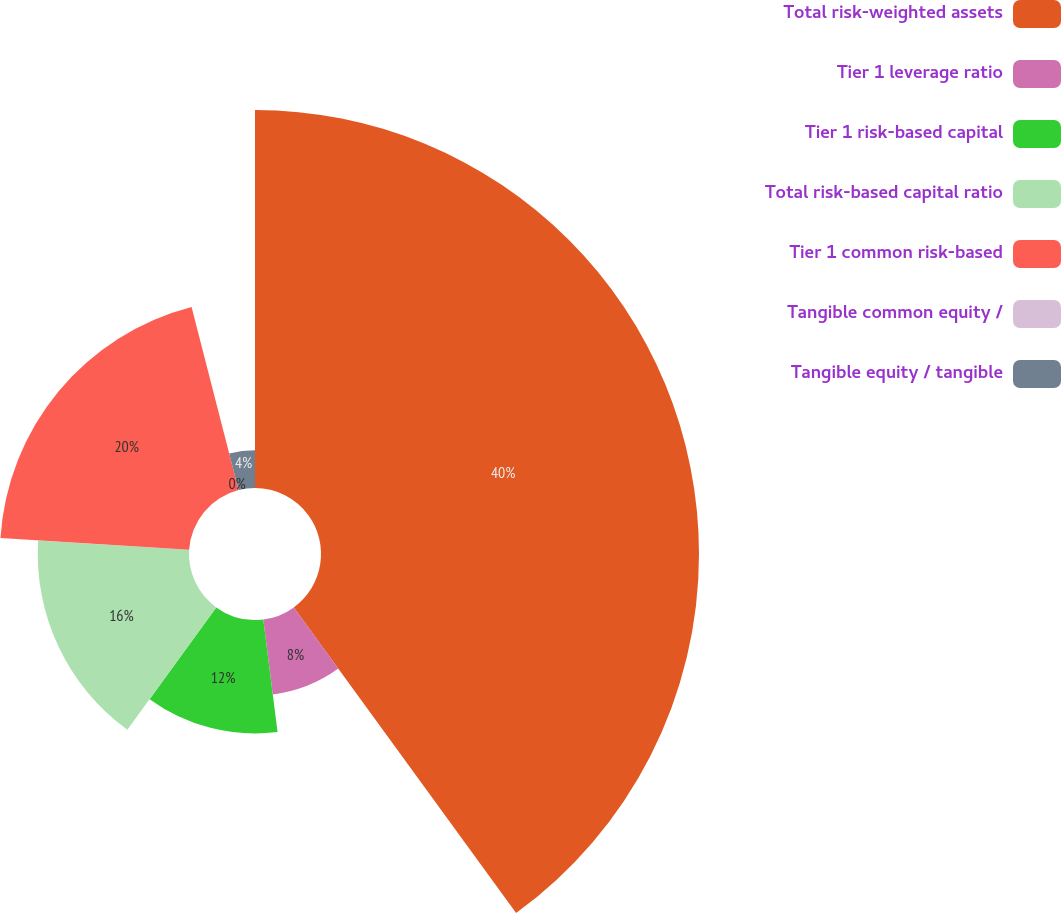Convert chart. <chart><loc_0><loc_0><loc_500><loc_500><pie_chart><fcel>Total risk-weighted assets<fcel>Tier 1 leverage ratio<fcel>Tier 1 risk-based capital<fcel>Total risk-based capital ratio<fcel>Tier 1 common risk-based<fcel>Tangible common equity /<fcel>Tangible equity / tangible<nl><fcel>39.99%<fcel>8.0%<fcel>12.0%<fcel>16.0%<fcel>20.0%<fcel>0.0%<fcel>4.0%<nl></chart> 